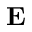<formula> <loc_0><loc_0><loc_500><loc_500>E</formula> 